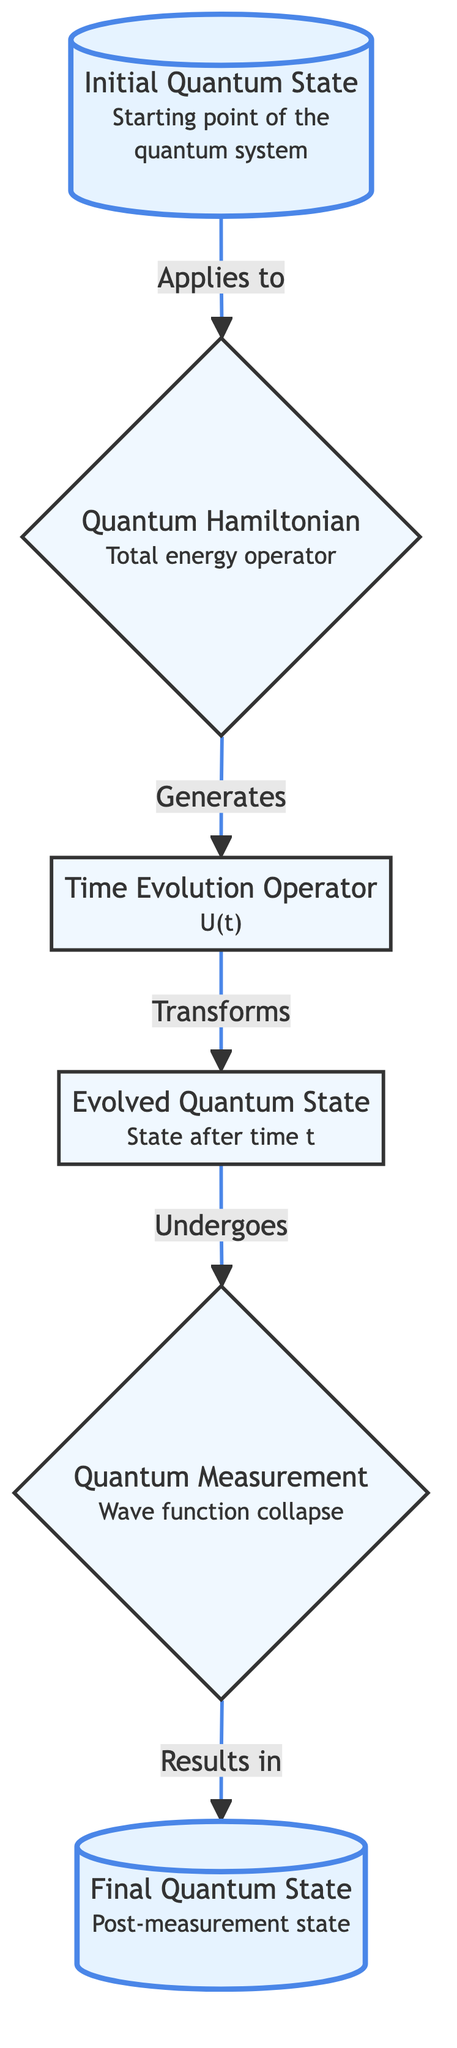What is the initial point of the quantum system? According to the flowchart, the initial point of the quantum system is labeled "Initial Quantum State," which represents the starting point of the quantum system.
Answer: Initial Quantum State Which operator governs the evolution of the quantum state? The flowchart indicates that the operator governing the evolution of the quantum state is the "Quantum Hamiltonian," which corresponds to the total energy of the system.
Answer: Quantum Hamiltonian How many main nodes are present in the diagram? By counting the main elements listed in the flowchart, there are six nodes: Initial Quantum State, Quantum Hamiltonian, Time Evolution Operator, Evolved Quantum State, Quantum Measurement, and Final Quantum State.
Answer: Six What does the Time Evolution Operator transform? The flowchart clearly states that the Time Evolution Operator transforms the "Initial Quantum State" over time to produce the "Evolved Quantum State."
Answer: Initial Quantum State What occurs after the Evolved Quantum State undergoes Quantum Measurement? The diagram specifies that after the Evolved Quantum State undergoes Quantum Measurement, it results in the "Final Quantum State," which is influenced by the measurement process.
Answer: Final Quantum State What relationship is represented between the Evolved Quantum State and Quantum Measurement? The flowchart shows that the Evolved Quantum State undergoes a process called Quantum Measurement, indicating a direct relationship where the measurement affects the state of the system.
Answer: Undergoes What is the final stage of the quantum evolution process? The final stage of the quantum evolution process, as depicted in the flowchart, is the "Final Quantum State," which is the state after measurement and may vary based on probabilities.
Answer: Final Quantum State Which element is represented as the starting point leading to measurement? The flowchart indicates that the "Evolved Quantum State" is the element that leads to the Quantum Measurement process, indicating that it is the intermediate point before measurement occurs.
Answer: Evolved Quantum State What type of operator is the Time Evolution Operator? The diagram classifies the Time Evolution Operator as a "unitary operator," indicating its nature within the context of quantum state transformation.
Answer: Unitary operator 